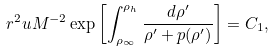<formula> <loc_0><loc_0><loc_500><loc_500>r ^ { 2 } u { M } ^ { - 2 } \exp \left [ \int ^ { \rho _ { h } } _ { \rho _ { \infty } } \frac { d \rho ^ { \prime } } { \rho ^ { \prime } + p ( \rho ^ { \prime } ) } \right ] = C _ { 1 } ,</formula> 